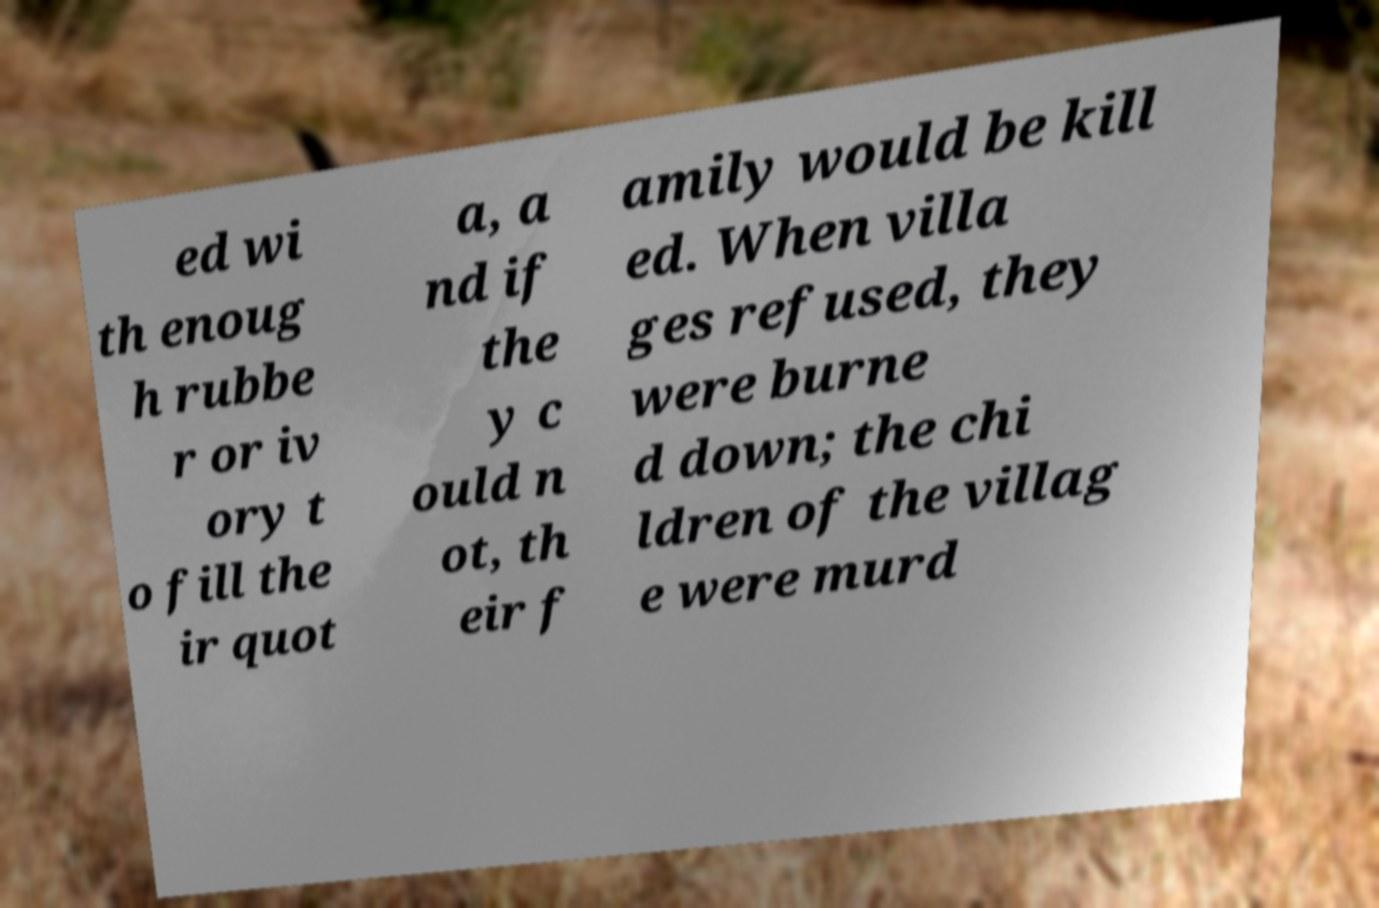There's text embedded in this image that I need extracted. Can you transcribe it verbatim? ed wi th enoug h rubbe r or iv ory t o fill the ir quot a, a nd if the y c ould n ot, th eir f amily would be kill ed. When villa ges refused, they were burne d down; the chi ldren of the villag e were murd 